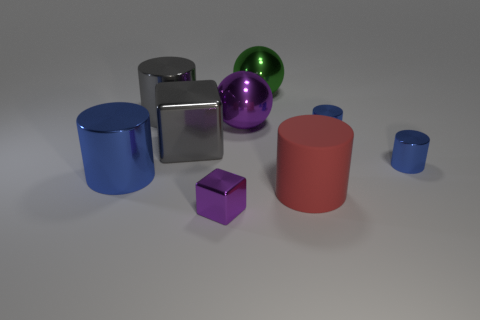Subtract all red cylinders. How many cylinders are left? 4 Subtract all green spheres. How many blue cylinders are left? 3 Subtract all large matte cylinders. How many cylinders are left? 4 Subtract 3 cylinders. How many cylinders are left? 2 Subtract all brown cylinders. Subtract all blue cubes. How many cylinders are left? 5 Subtract all spheres. How many objects are left? 7 Subtract all shiny objects. Subtract all tiny yellow rubber balls. How many objects are left? 1 Add 2 large cylinders. How many large cylinders are left? 5 Add 2 gray metallic objects. How many gray metallic objects exist? 4 Subtract 0 yellow cylinders. How many objects are left? 9 